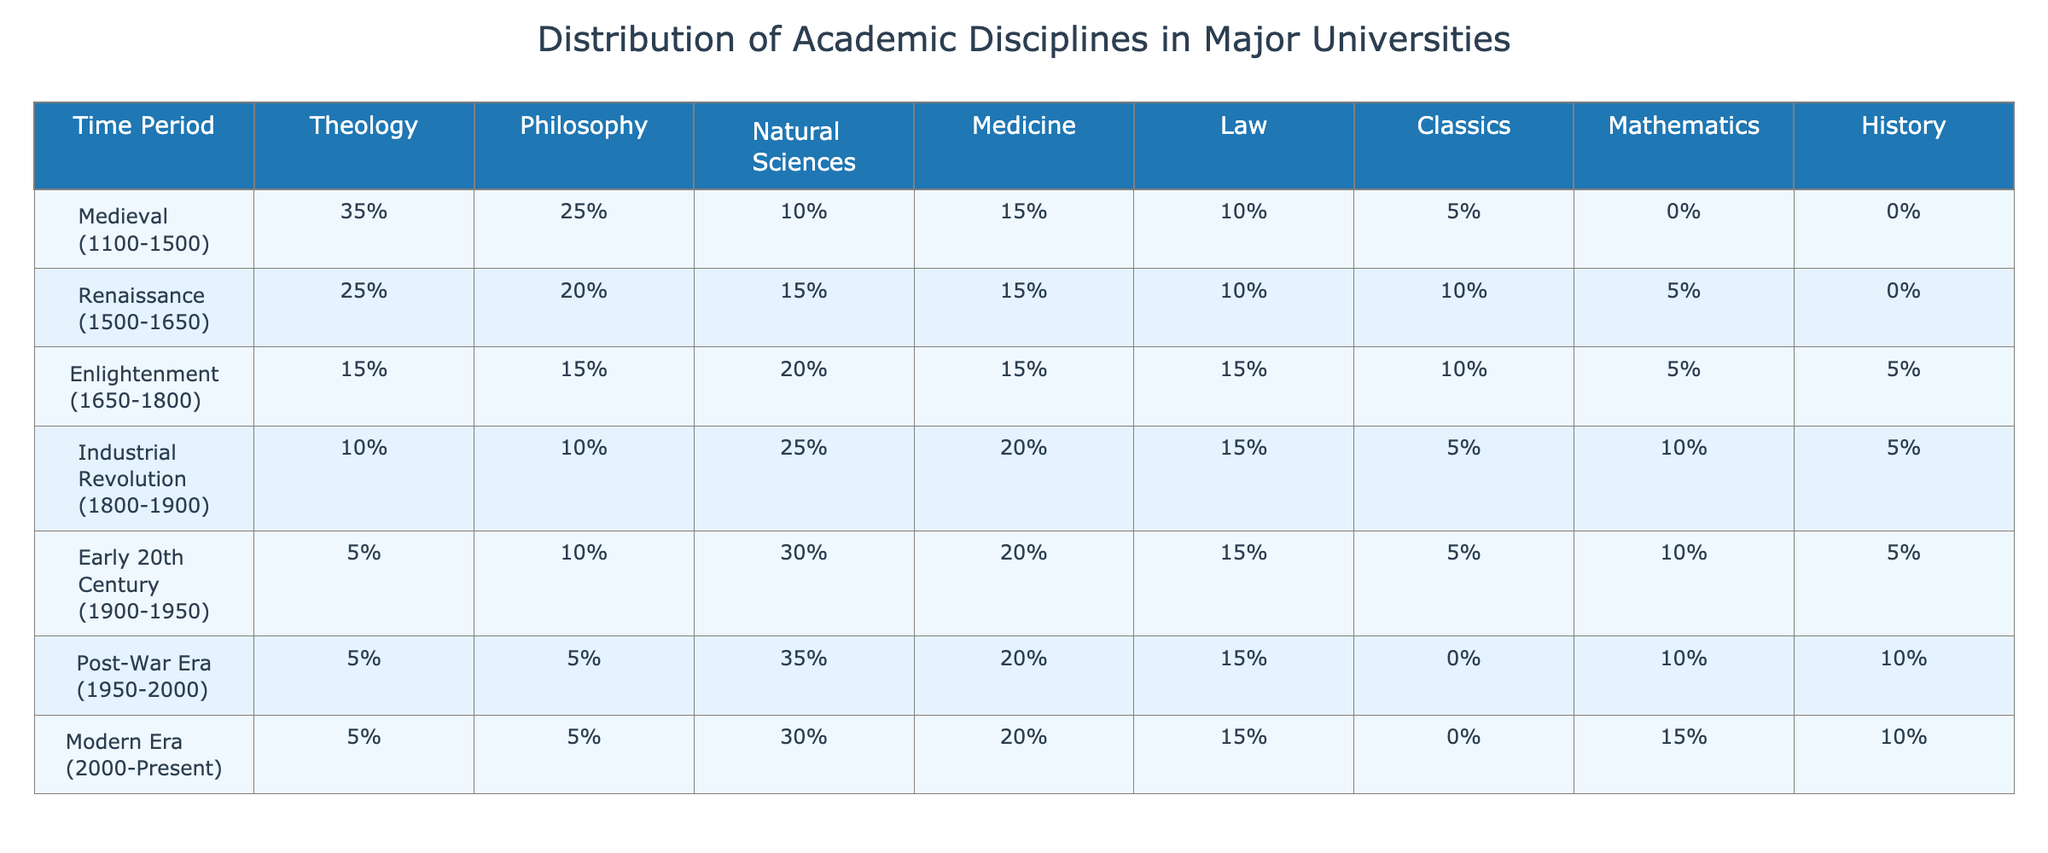What is the distribution of Theology during the Medieval period? According to the table, the percentage of Theology during the Medieval period (1100-1500) is 35%.
Answer: 35% Which discipline saw the highest percentage in the Enlightenment period? In the Enlightenment period (1650-1800), the Natural Sciences had the highest percentage at 20%.
Answer: Natural Sciences How much did the percentage of Philosophy decrease from the Medieval period to the Renaissance? In the Medieval period, Philosophy accounted for 25%, while in the Renaissance, it decreased to 20%. The difference is 25% - 20% = 5%.
Answer: 5% What percentage of academic disciplines combined was devoted to Classics in the Industrial Revolution? Classics accounted for 5% during the Industrial Revolution (1800-1900).
Answer: 5% Did the percentage of Natural Sciences increase or decrease from the Medieval period to the Early 20th Century? The percentage of Natural Sciences decreased from 10% in the Medieval period to 30% in the Early 20th Century, indicating an increase.
Answer: Increase What was the average percentage of Law across all the periods listed? The percentages for Law are: 10%, 10%, 15%, 15%, 15%, 15%, and 15%. Summing these gives 10 + 10 + 15 + 15 + 15 + 15 + 15 = 95%, and there are 7 periods, so the average is 95% / 7 = 13.57%.
Answer: Approximately 13.57% Which period had the lowest percentage in Mathematics, and what was that percentage? The Medieval period had 0% Mathematics, which is the lowest across all periods.
Answer: 0% What was the change in the percentage of Medicine from the Renaissance to the Post-War Era? Medicine in the Renaissance was 15%, and in the Post-War Era it remained at 20%. The change is 20% - 15% = 5%, indicating an increase.
Answer: Increase of 5% What percentage do Theology and Philosophy combined represent in the Modern Era? In the Modern Era (2000-Present), Theology is 5% and Philosophy is also 5%. Combined, they total 5% + 5% = 10%.
Answer: 10% Is it true that the percentage of History was higher in the Early 20th Century than in the Medieval period? In the Early 20th Century, the percentage of History was 5%, while in the Medieval period it was 0%. Thus, it is true that it was higher in the Early 20th Century.
Answer: True How does the percentage of Natural Sciences in the Industrial Revolution compare to that in the Post-War Era? The percentage of Natural Sciences was 25% during the Industrial Revolution and decreased to 35% in the Post-War Era. The comparison shows an increase.
Answer: Increase 